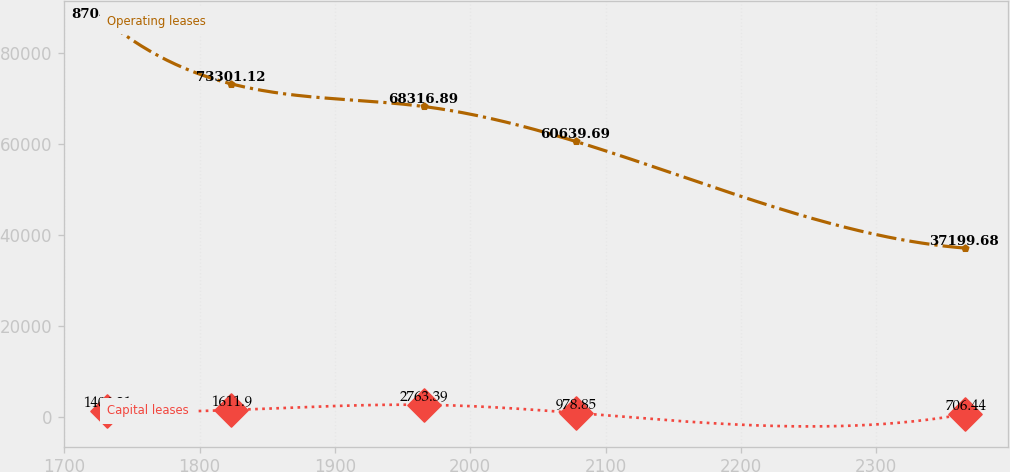<chart> <loc_0><loc_0><loc_500><loc_500><line_chart><ecel><fcel>Operating leases<fcel>Capital leases<nl><fcel>1731.36<fcel>87042<fcel>1406.21<nl><fcel>1823.23<fcel>73301.1<fcel>1611.9<nl><fcel>1965.55<fcel>68316.9<fcel>2763.39<nl><fcel>2077.96<fcel>60639.7<fcel>978.85<nl><fcel>2365.82<fcel>37199.7<fcel>706.44<nl></chart> 